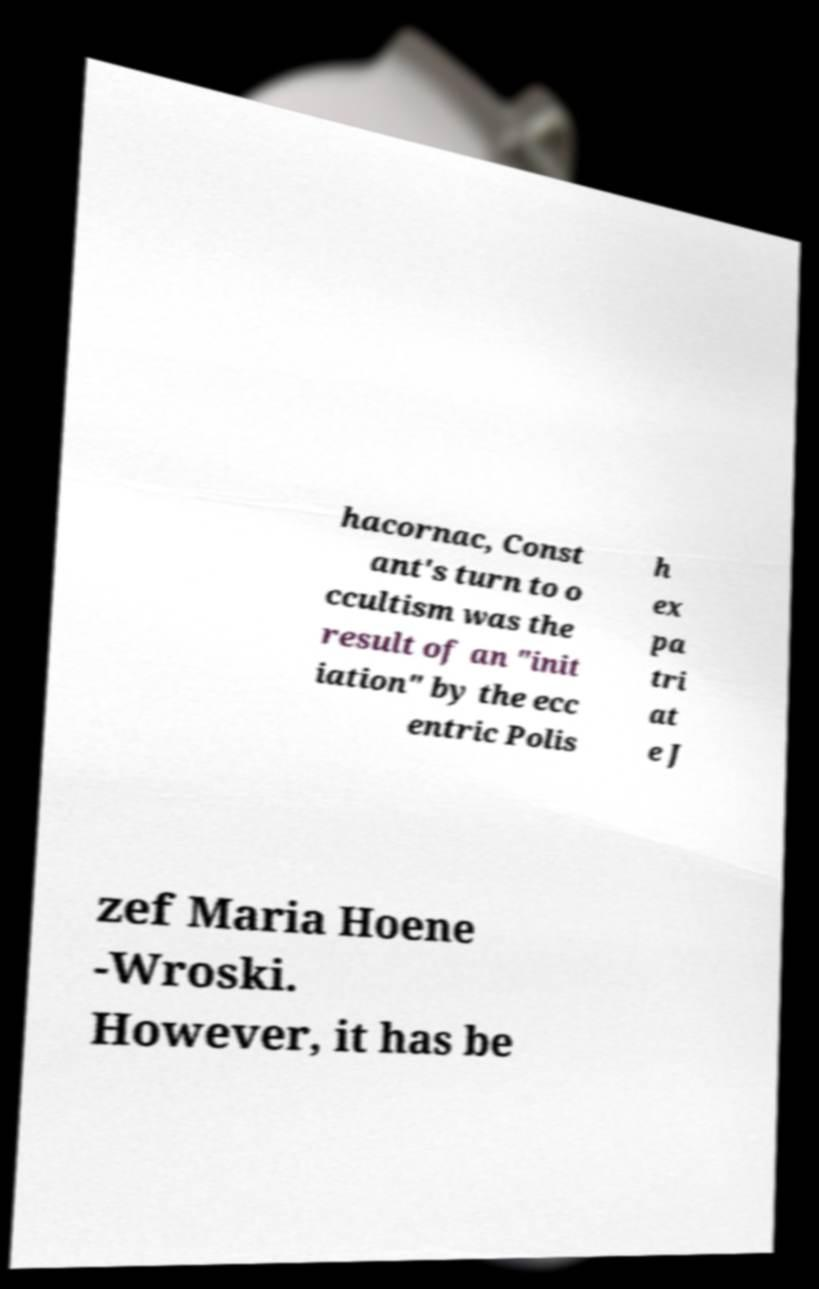Please identify and transcribe the text found in this image. hacornac, Const ant's turn to o ccultism was the result of an "init iation" by the ecc entric Polis h ex pa tri at e J zef Maria Hoene -Wroski. However, it has be 